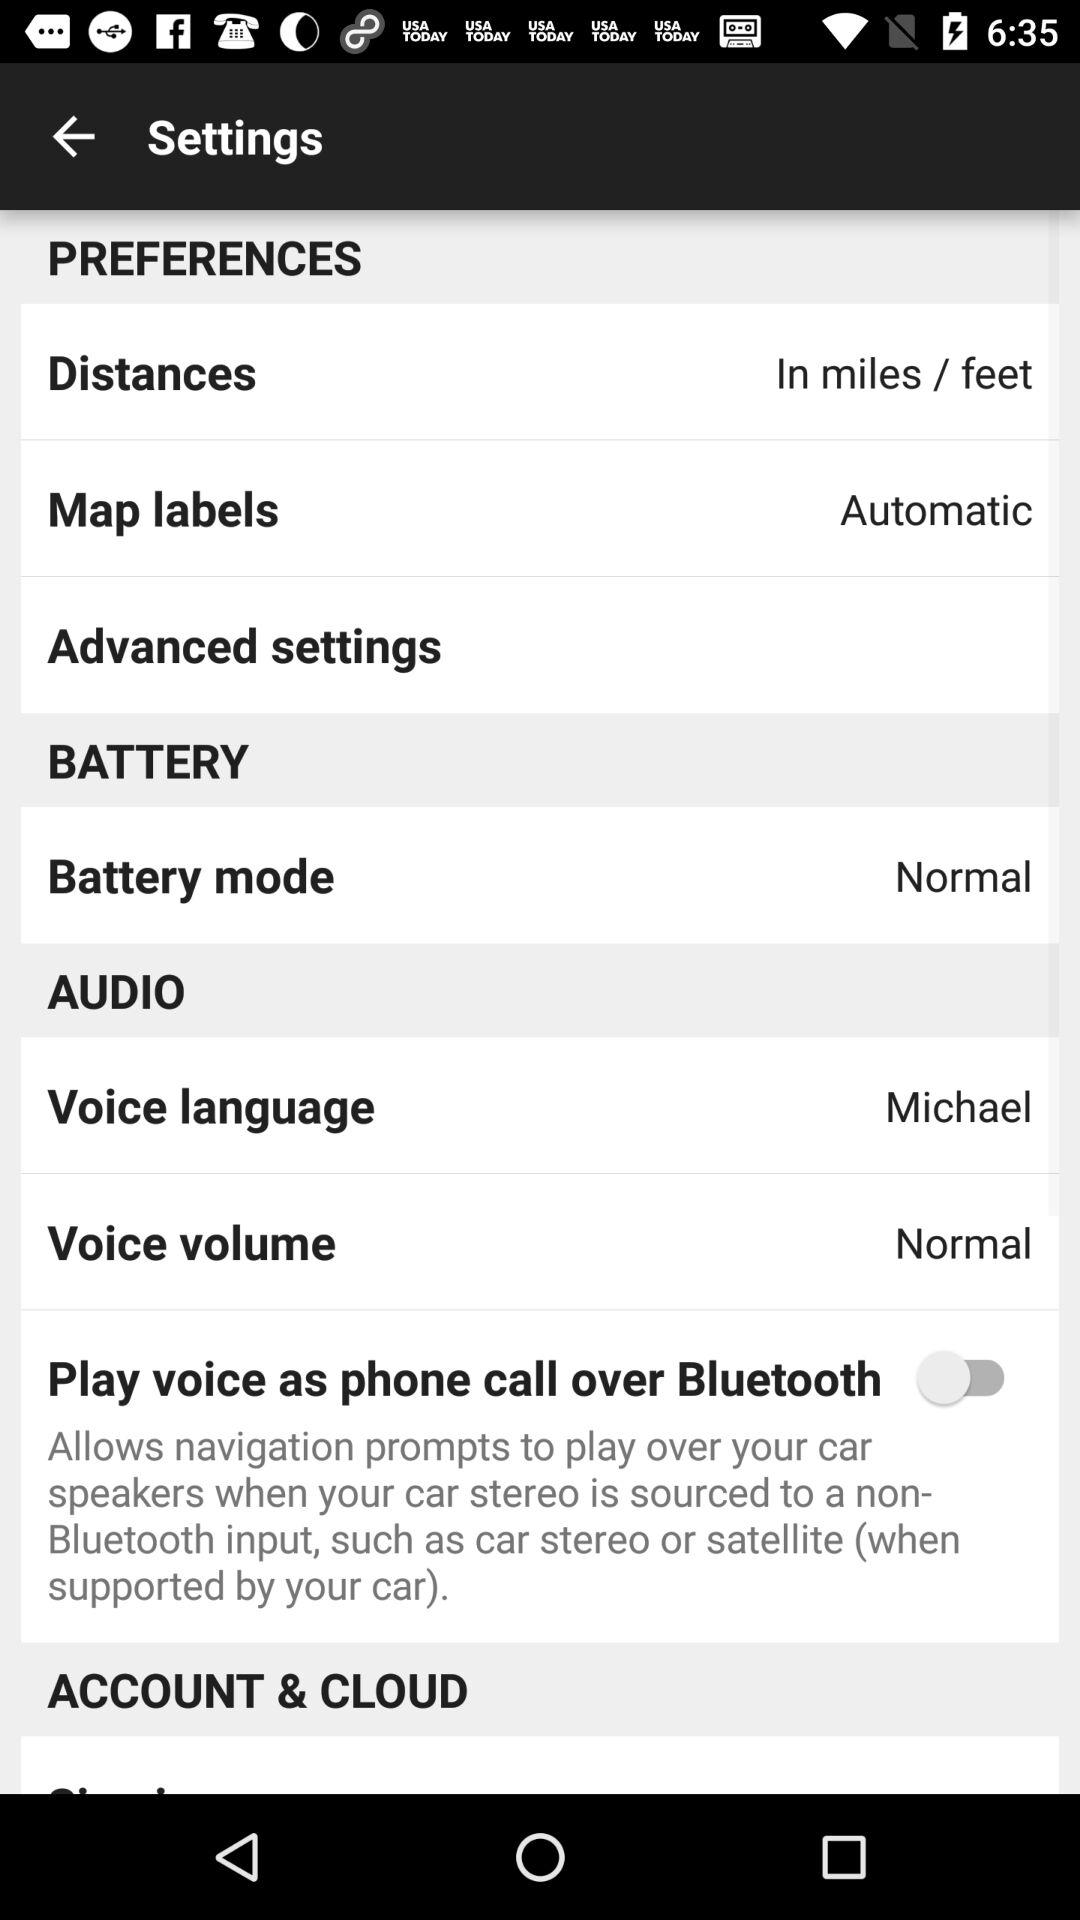What is "Map labels"? The "Map labels" is Automatic. 